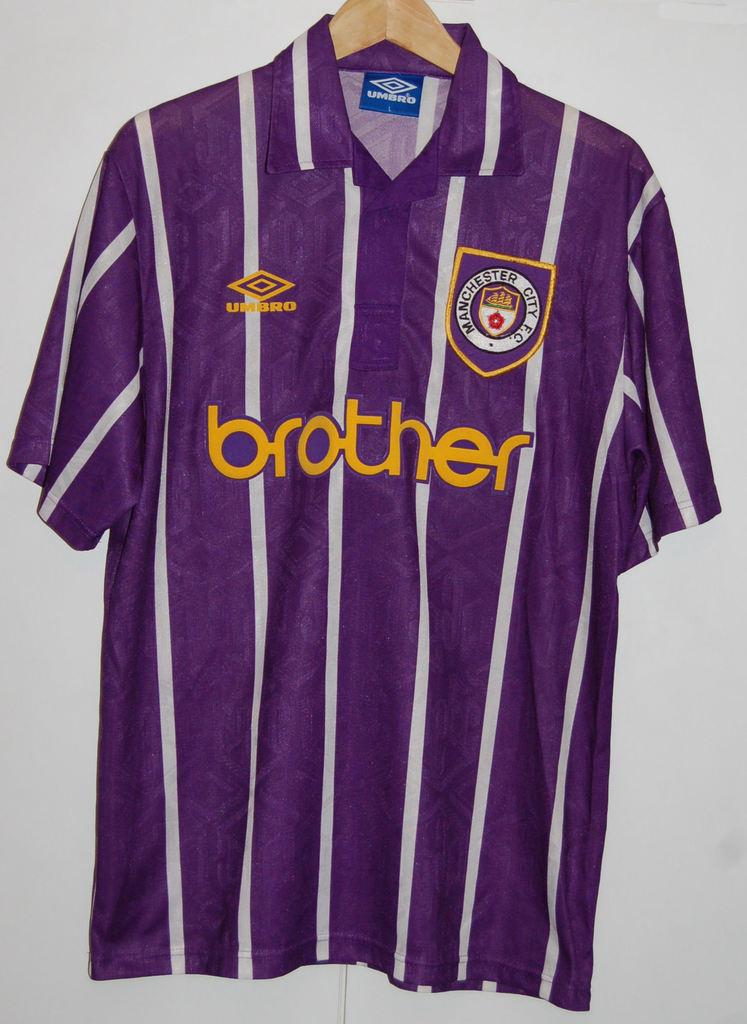What sibling type is shown in large text across the front of this shirt?
Make the answer very short. Brother. What brand is the shirt?
Keep it short and to the point. Umbro. 